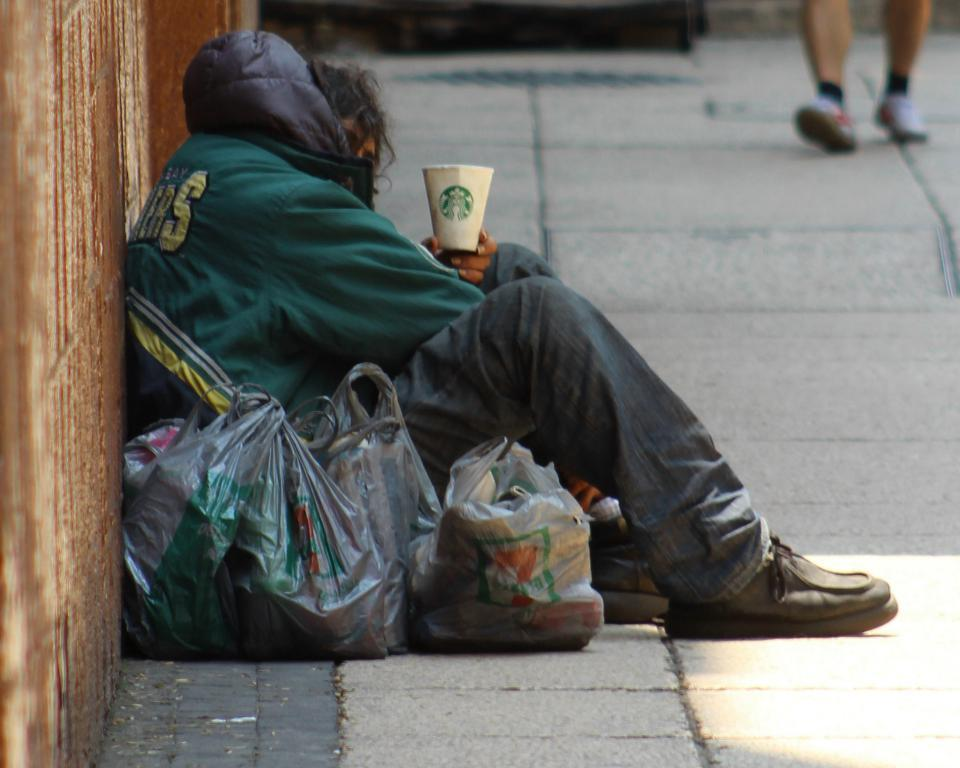What is the person in the image holding? The person is holding a cup in the image. Where is the person sitting? The person is sitting on a path. Are there any other people in the image? Yes, there are other persons in the image. What can be seen covering something in the image? There are covers visible in the image. What type of structure is present in the image? There is a wall in the image. What type of pollution can be seen in the image? There is no pollution visible in the image. How many dolls are present in the image? There are no dolls present in the image. 